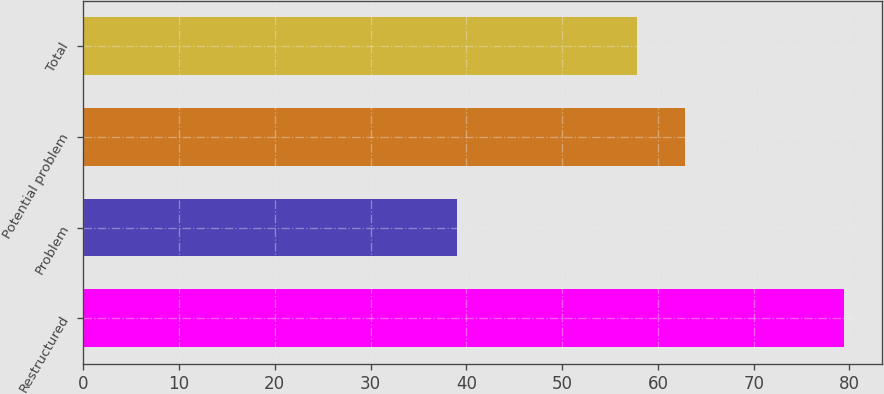<chart> <loc_0><loc_0><loc_500><loc_500><bar_chart><fcel>Restructured<fcel>Problem<fcel>Potential problem<fcel>Total<nl><fcel>79.4<fcel>39<fcel>62.8<fcel>57.8<nl></chart> 